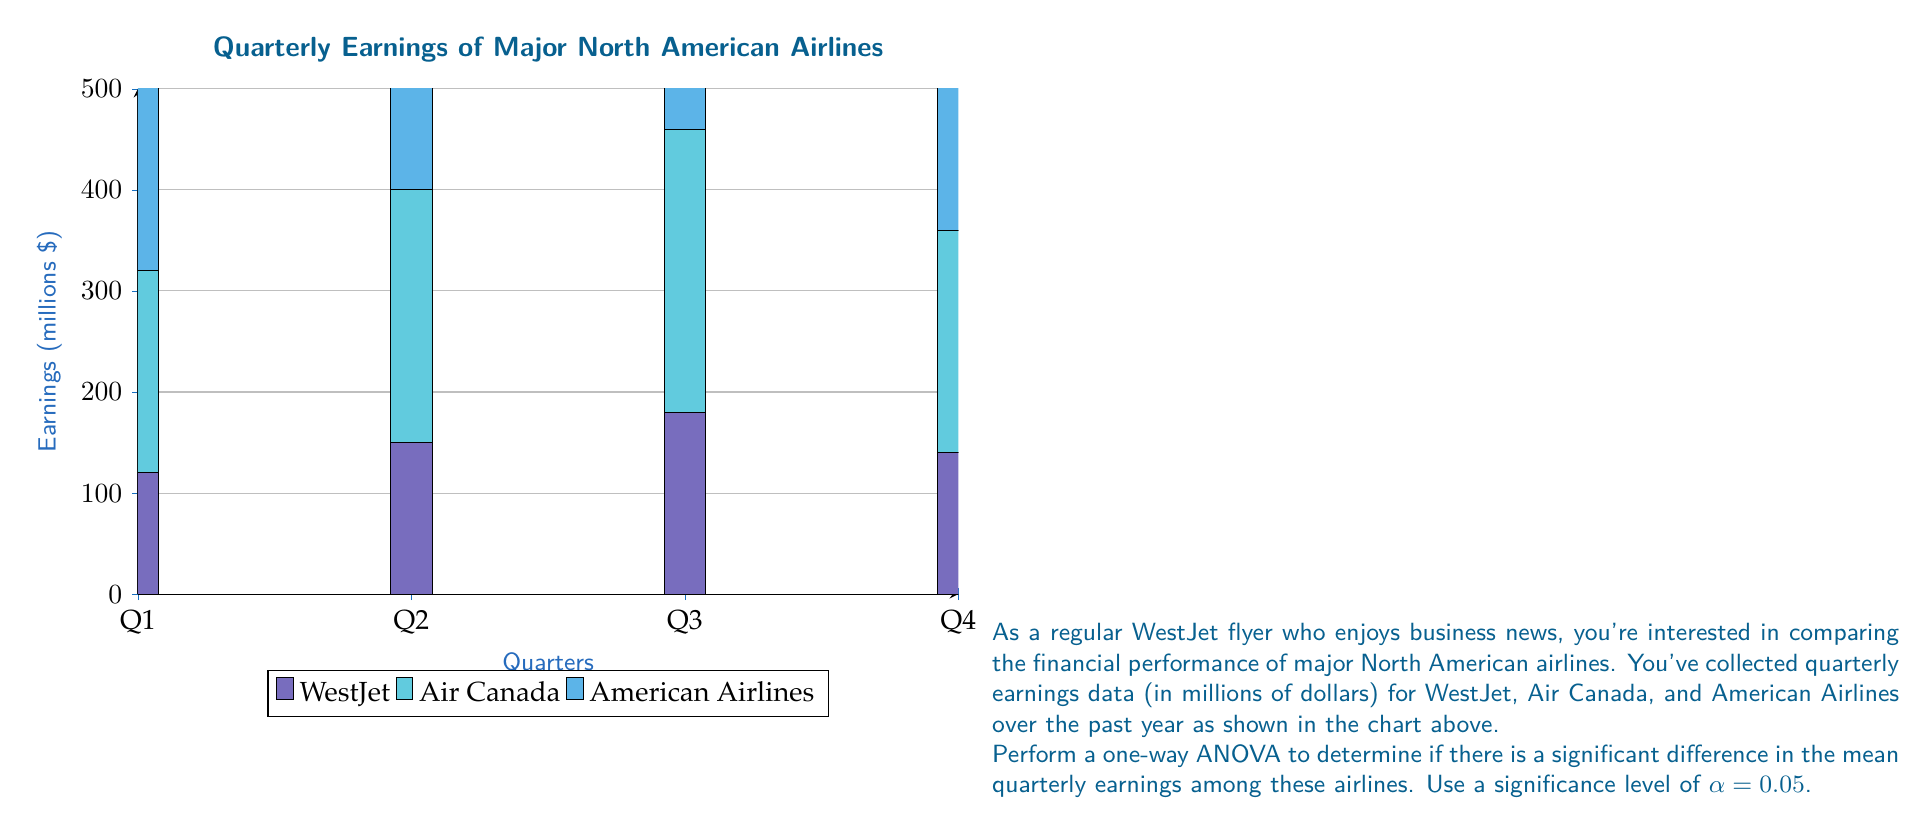Give your solution to this math problem. Let's perform a one-way ANOVA step-by-step:

1) First, calculate the overall mean and group means:
   Overall mean: $\bar{X} = \frac{2720}{12} = 226.67$
   WestJet mean: $\bar{X}_1 = 147.5$
   Air Canada mean: $\bar{X}_2 = 237.5$
   American Airlines mean: $\bar{X}_3 = 395$

2) Calculate the Sum of Squares Between (SSB):
   $$SSB = \sum_{i=1}^{k} n_i(\bar{X}_i - \bar{X})^2$$
   $$SSB = 4(147.5 - 226.67)^2 + 4(237.5 - 226.67)^2 + 4(395 - 226.67)^2 = 156,406.25$$

3) Calculate the Sum of Squares Within (SSW):
   $$SSW = \sum_{i=1}^{k} \sum_{j=1}^{n_i} (X_{ij} - \bar{X}_i)^2$$
   $$SSW = 1,900 + 4,300 + 5,300 = 11,500$$

4) Calculate the Sum of Squares Total (SST):
   $$SST = SSB + SSW = 156,406.25 + 11,500 = 167,906.25$$

5) Calculate the degrees of freedom:
   $$df_{between} = k - 1 = 2$$
   $$df_{within} = N - k = 9$$
   $$df_{total} = N - 1 = 11$$

6) Calculate the Mean Square Between (MSB) and Mean Square Within (MSW):
   $$MSB = \frac{SSB}{df_{between}} = \frac{156,406.25}{2} = 78,203.125$$
   $$MSW = \frac{SSW}{df_{within}} = \frac{11,500}{9} = 1,277.78$$

7) Calculate the F-statistic:
   $$F = \frac{MSB}{MSW} = \frac{78,203.125}{1,277.78} = 61.20$$

8) Find the critical F-value:
   For $\alpha = 0.05$, $df_{between} = 2$, and $df_{within} = 9$, 
   $F_{critical} = 4.26$ (from F-distribution table)

9) Compare F-statistic to F-critical:
   Since $61.20 > 4.26$, we reject the null hypothesis.

Therefore, there is a significant difference in mean quarterly earnings among the airlines at the 0.05 significance level.
Answer: Reject null hypothesis; significant difference in mean quarterly earnings (F = 61.20, p < 0.05) 